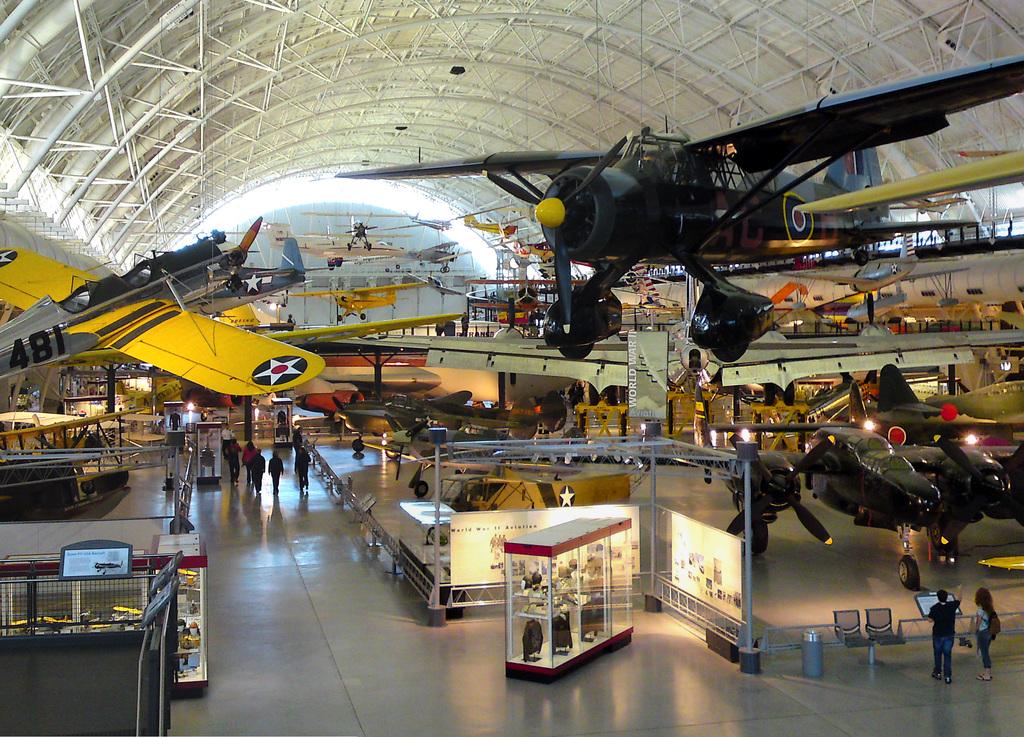What number is on the grey and yellow plane?
Your answer should be very brief. 481. 